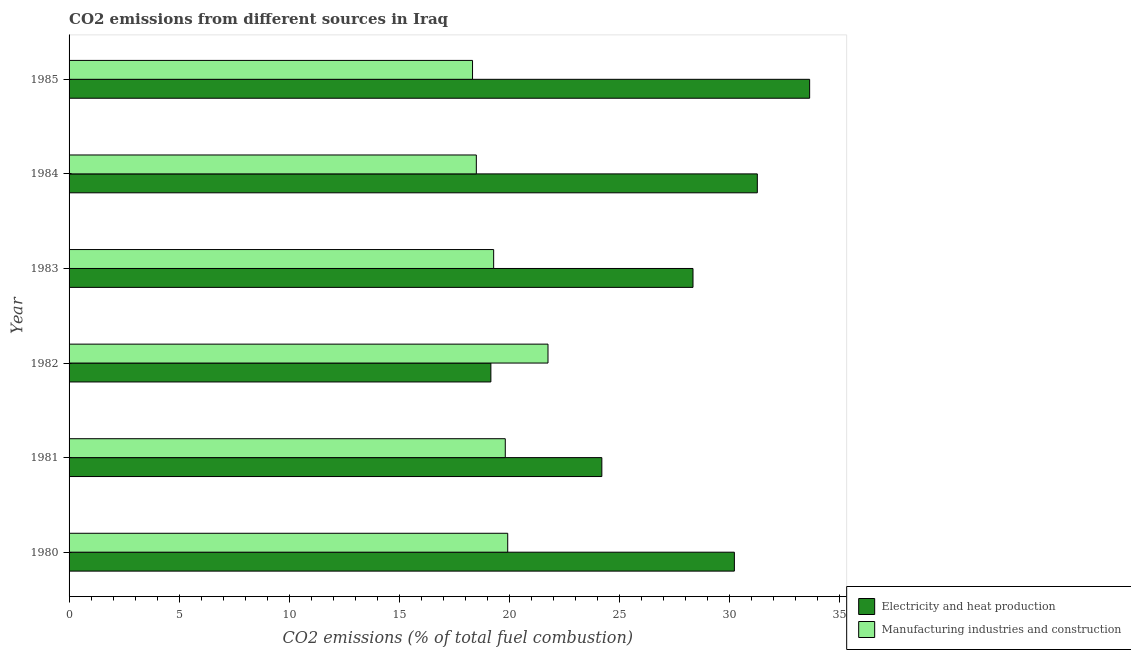How many different coloured bars are there?
Your response must be concise. 2. How many groups of bars are there?
Offer a terse response. 6. Are the number of bars per tick equal to the number of legend labels?
Offer a terse response. Yes. Are the number of bars on each tick of the Y-axis equal?
Provide a succinct answer. Yes. How many bars are there on the 3rd tick from the bottom?
Give a very brief answer. 2. What is the label of the 4th group of bars from the top?
Give a very brief answer. 1982. In how many cases, is the number of bars for a given year not equal to the number of legend labels?
Your answer should be very brief. 0. What is the co2 emissions due to electricity and heat production in 1980?
Provide a succinct answer. 30.22. Across all years, what is the maximum co2 emissions due to electricity and heat production?
Your answer should be compact. 33.64. Across all years, what is the minimum co2 emissions due to manufacturing industries?
Your answer should be very brief. 18.33. In which year was the co2 emissions due to electricity and heat production minimum?
Offer a terse response. 1982. What is the total co2 emissions due to manufacturing industries in the graph?
Offer a terse response. 117.61. What is the difference between the co2 emissions due to manufacturing industries in 1981 and that in 1985?
Provide a succinct answer. 1.49. What is the difference between the co2 emissions due to electricity and heat production in 1985 and the co2 emissions due to manufacturing industries in 1980?
Give a very brief answer. 13.72. What is the average co2 emissions due to manufacturing industries per year?
Ensure brevity in your answer.  19.6. In the year 1981, what is the difference between the co2 emissions due to electricity and heat production and co2 emissions due to manufacturing industries?
Provide a short and direct response. 4.39. What is the ratio of the co2 emissions due to manufacturing industries in 1984 to that in 1985?
Your response must be concise. 1.01. Is the co2 emissions due to manufacturing industries in 1981 less than that in 1983?
Make the answer very short. No. What is the difference between the highest and the second highest co2 emissions due to manufacturing industries?
Your answer should be very brief. 1.83. What is the difference between the highest and the lowest co2 emissions due to manufacturing industries?
Provide a succinct answer. 3.43. In how many years, is the co2 emissions due to electricity and heat production greater than the average co2 emissions due to electricity and heat production taken over all years?
Offer a very short reply. 4. Is the sum of the co2 emissions due to electricity and heat production in 1980 and 1983 greater than the maximum co2 emissions due to manufacturing industries across all years?
Provide a succinct answer. Yes. What does the 1st bar from the top in 1983 represents?
Give a very brief answer. Manufacturing industries and construction. What does the 1st bar from the bottom in 1983 represents?
Keep it short and to the point. Electricity and heat production. How many bars are there?
Keep it short and to the point. 12. Are all the bars in the graph horizontal?
Your answer should be compact. Yes. What is the difference between two consecutive major ticks on the X-axis?
Offer a terse response. 5. Does the graph contain any zero values?
Offer a very short reply. No. Where does the legend appear in the graph?
Ensure brevity in your answer.  Bottom right. What is the title of the graph?
Give a very brief answer. CO2 emissions from different sources in Iraq. What is the label or title of the X-axis?
Your answer should be very brief. CO2 emissions (% of total fuel combustion). What is the label or title of the Y-axis?
Offer a very short reply. Year. What is the CO2 emissions (% of total fuel combustion) in Electricity and heat production in 1980?
Keep it short and to the point. 30.22. What is the CO2 emissions (% of total fuel combustion) of Manufacturing industries and construction in 1980?
Your answer should be compact. 19.93. What is the CO2 emissions (% of total fuel combustion) in Electricity and heat production in 1981?
Your answer should be compact. 24.2. What is the CO2 emissions (% of total fuel combustion) of Manufacturing industries and construction in 1981?
Provide a succinct answer. 19.82. What is the CO2 emissions (% of total fuel combustion) of Electricity and heat production in 1982?
Keep it short and to the point. 19.16. What is the CO2 emissions (% of total fuel combustion) in Manufacturing industries and construction in 1982?
Your answer should be very brief. 21.76. What is the CO2 emissions (% of total fuel combustion) of Electricity and heat production in 1983?
Provide a short and direct response. 28.34. What is the CO2 emissions (% of total fuel combustion) in Manufacturing industries and construction in 1983?
Make the answer very short. 19.29. What is the CO2 emissions (% of total fuel combustion) of Electricity and heat production in 1984?
Offer a very short reply. 31.26. What is the CO2 emissions (% of total fuel combustion) of Manufacturing industries and construction in 1984?
Your response must be concise. 18.5. What is the CO2 emissions (% of total fuel combustion) in Electricity and heat production in 1985?
Your answer should be very brief. 33.64. What is the CO2 emissions (% of total fuel combustion) in Manufacturing industries and construction in 1985?
Give a very brief answer. 18.33. Across all years, what is the maximum CO2 emissions (% of total fuel combustion) in Electricity and heat production?
Provide a succinct answer. 33.64. Across all years, what is the maximum CO2 emissions (% of total fuel combustion) in Manufacturing industries and construction?
Offer a terse response. 21.76. Across all years, what is the minimum CO2 emissions (% of total fuel combustion) in Electricity and heat production?
Make the answer very short. 19.16. Across all years, what is the minimum CO2 emissions (% of total fuel combustion) of Manufacturing industries and construction?
Your response must be concise. 18.33. What is the total CO2 emissions (% of total fuel combustion) in Electricity and heat production in the graph?
Your answer should be compact. 166.83. What is the total CO2 emissions (% of total fuel combustion) in Manufacturing industries and construction in the graph?
Give a very brief answer. 117.61. What is the difference between the CO2 emissions (% of total fuel combustion) of Electricity and heat production in 1980 and that in 1981?
Your response must be concise. 6.02. What is the difference between the CO2 emissions (% of total fuel combustion) in Manufacturing industries and construction in 1980 and that in 1981?
Provide a succinct answer. 0.11. What is the difference between the CO2 emissions (% of total fuel combustion) of Electricity and heat production in 1980 and that in 1982?
Make the answer very short. 11.06. What is the difference between the CO2 emissions (% of total fuel combustion) of Manufacturing industries and construction in 1980 and that in 1982?
Make the answer very short. -1.83. What is the difference between the CO2 emissions (% of total fuel combustion) in Electricity and heat production in 1980 and that in 1983?
Provide a short and direct response. 1.88. What is the difference between the CO2 emissions (% of total fuel combustion) of Manufacturing industries and construction in 1980 and that in 1983?
Make the answer very short. 0.64. What is the difference between the CO2 emissions (% of total fuel combustion) in Electricity and heat production in 1980 and that in 1984?
Your answer should be very brief. -1.04. What is the difference between the CO2 emissions (% of total fuel combustion) of Manufacturing industries and construction in 1980 and that in 1984?
Give a very brief answer. 1.43. What is the difference between the CO2 emissions (% of total fuel combustion) in Electricity and heat production in 1980 and that in 1985?
Keep it short and to the point. -3.42. What is the difference between the CO2 emissions (% of total fuel combustion) in Manufacturing industries and construction in 1980 and that in 1985?
Offer a very short reply. 1.6. What is the difference between the CO2 emissions (% of total fuel combustion) in Electricity and heat production in 1981 and that in 1982?
Make the answer very short. 5.04. What is the difference between the CO2 emissions (% of total fuel combustion) in Manufacturing industries and construction in 1981 and that in 1982?
Your answer should be very brief. -1.94. What is the difference between the CO2 emissions (% of total fuel combustion) of Electricity and heat production in 1981 and that in 1983?
Your answer should be compact. -4.14. What is the difference between the CO2 emissions (% of total fuel combustion) of Manufacturing industries and construction in 1981 and that in 1983?
Your response must be concise. 0.53. What is the difference between the CO2 emissions (% of total fuel combustion) of Electricity and heat production in 1981 and that in 1984?
Keep it short and to the point. -7.06. What is the difference between the CO2 emissions (% of total fuel combustion) of Manufacturing industries and construction in 1981 and that in 1984?
Provide a short and direct response. 1.32. What is the difference between the CO2 emissions (% of total fuel combustion) in Electricity and heat production in 1981 and that in 1985?
Offer a terse response. -9.44. What is the difference between the CO2 emissions (% of total fuel combustion) in Manufacturing industries and construction in 1981 and that in 1985?
Give a very brief answer. 1.49. What is the difference between the CO2 emissions (% of total fuel combustion) of Electricity and heat production in 1982 and that in 1983?
Provide a succinct answer. -9.18. What is the difference between the CO2 emissions (% of total fuel combustion) of Manufacturing industries and construction in 1982 and that in 1983?
Give a very brief answer. 2.47. What is the difference between the CO2 emissions (% of total fuel combustion) in Electricity and heat production in 1982 and that in 1984?
Provide a short and direct response. -12.1. What is the difference between the CO2 emissions (% of total fuel combustion) of Manufacturing industries and construction in 1982 and that in 1984?
Keep it short and to the point. 3.26. What is the difference between the CO2 emissions (% of total fuel combustion) in Electricity and heat production in 1982 and that in 1985?
Provide a short and direct response. -14.48. What is the difference between the CO2 emissions (% of total fuel combustion) of Manufacturing industries and construction in 1982 and that in 1985?
Your response must be concise. 3.43. What is the difference between the CO2 emissions (% of total fuel combustion) in Electricity and heat production in 1983 and that in 1984?
Your answer should be very brief. -2.92. What is the difference between the CO2 emissions (% of total fuel combustion) of Manufacturing industries and construction in 1983 and that in 1984?
Your answer should be compact. 0.79. What is the difference between the CO2 emissions (% of total fuel combustion) in Electricity and heat production in 1983 and that in 1985?
Your answer should be very brief. -5.3. What is the difference between the CO2 emissions (% of total fuel combustion) of Manufacturing industries and construction in 1983 and that in 1985?
Provide a succinct answer. 0.96. What is the difference between the CO2 emissions (% of total fuel combustion) of Electricity and heat production in 1984 and that in 1985?
Provide a succinct answer. -2.38. What is the difference between the CO2 emissions (% of total fuel combustion) in Manufacturing industries and construction in 1984 and that in 1985?
Keep it short and to the point. 0.17. What is the difference between the CO2 emissions (% of total fuel combustion) of Electricity and heat production in 1980 and the CO2 emissions (% of total fuel combustion) of Manufacturing industries and construction in 1981?
Ensure brevity in your answer.  10.41. What is the difference between the CO2 emissions (% of total fuel combustion) in Electricity and heat production in 1980 and the CO2 emissions (% of total fuel combustion) in Manufacturing industries and construction in 1982?
Your response must be concise. 8.47. What is the difference between the CO2 emissions (% of total fuel combustion) of Electricity and heat production in 1980 and the CO2 emissions (% of total fuel combustion) of Manufacturing industries and construction in 1983?
Your response must be concise. 10.93. What is the difference between the CO2 emissions (% of total fuel combustion) in Electricity and heat production in 1980 and the CO2 emissions (% of total fuel combustion) in Manufacturing industries and construction in 1984?
Provide a short and direct response. 11.72. What is the difference between the CO2 emissions (% of total fuel combustion) of Electricity and heat production in 1980 and the CO2 emissions (% of total fuel combustion) of Manufacturing industries and construction in 1985?
Your response must be concise. 11.89. What is the difference between the CO2 emissions (% of total fuel combustion) in Electricity and heat production in 1981 and the CO2 emissions (% of total fuel combustion) in Manufacturing industries and construction in 1982?
Offer a terse response. 2.45. What is the difference between the CO2 emissions (% of total fuel combustion) of Electricity and heat production in 1981 and the CO2 emissions (% of total fuel combustion) of Manufacturing industries and construction in 1983?
Give a very brief answer. 4.91. What is the difference between the CO2 emissions (% of total fuel combustion) in Electricity and heat production in 1981 and the CO2 emissions (% of total fuel combustion) in Manufacturing industries and construction in 1984?
Ensure brevity in your answer.  5.7. What is the difference between the CO2 emissions (% of total fuel combustion) in Electricity and heat production in 1981 and the CO2 emissions (% of total fuel combustion) in Manufacturing industries and construction in 1985?
Offer a terse response. 5.87. What is the difference between the CO2 emissions (% of total fuel combustion) in Electricity and heat production in 1982 and the CO2 emissions (% of total fuel combustion) in Manufacturing industries and construction in 1983?
Make the answer very short. -0.13. What is the difference between the CO2 emissions (% of total fuel combustion) of Electricity and heat production in 1982 and the CO2 emissions (% of total fuel combustion) of Manufacturing industries and construction in 1984?
Give a very brief answer. 0.66. What is the difference between the CO2 emissions (% of total fuel combustion) of Electricity and heat production in 1982 and the CO2 emissions (% of total fuel combustion) of Manufacturing industries and construction in 1985?
Offer a very short reply. 0.83. What is the difference between the CO2 emissions (% of total fuel combustion) in Electricity and heat production in 1983 and the CO2 emissions (% of total fuel combustion) in Manufacturing industries and construction in 1984?
Your answer should be very brief. 9.84. What is the difference between the CO2 emissions (% of total fuel combustion) of Electricity and heat production in 1983 and the CO2 emissions (% of total fuel combustion) of Manufacturing industries and construction in 1985?
Give a very brief answer. 10.02. What is the difference between the CO2 emissions (% of total fuel combustion) of Electricity and heat production in 1984 and the CO2 emissions (% of total fuel combustion) of Manufacturing industries and construction in 1985?
Offer a terse response. 12.94. What is the average CO2 emissions (% of total fuel combustion) in Electricity and heat production per year?
Make the answer very short. 27.81. What is the average CO2 emissions (% of total fuel combustion) of Manufacturing industries and construction per year?
Provide a short and direct response. 19.6. In the year 1980, what is the difference between the CO2 emissions (% of total fuel combustion) in Electricity and heat production and CO2 emissions (% of total fuel combustion) in Manufacturing industries and construction?
Your response must be concise. 10.3. In the year 1981, what is the difference between the CO2 emissions (% of total fuel combustion) in Electricity and heat production and CO2 emissions (% of total fuel combustion) in Manufacturing industries and construction?
Give a very brief answer. 4.39. In the year 1982, what is the difference between the CO2 emissions (% of total fuel combustion) of Electricity and heat production and CO2 emissions (% of total fuel combustion) of Manufacturing industries and construction?
Offer a very short reply. -2.6. In the year 1983, what is the difference between the CO2 emissions (% of total fuel combustion) in Electricity and heat production and CO2 emissions (% of total fuel combustion) in Manufacturing industries and construction?
Keep it short and to the point. 9.06. In the year 1984, what is the difference between the CO2 emissions (% of total fuel combustion) in Electricity and heat production and CO2 emissions (% of total fuel combustion) in Manufacturing industries and construction?
Your response must be concise. 12.76. In the year 1985, what is the difference between the CO2 emissions (% of total fuel combustion) in Electricity and heat production and CO2 emissions (% of total fuel combustion) in Manufacturing industries and construction?
Provide a succinct answer. 15.31. What is the ratio of the CO2 emissions (% of total fuel combustion) in Electricity and heat production in 1980 to that in 1981?
Provide a succinct answer. 1.25. What is the ratio of the CO2 emissions (% of total fuel combustion) of Manufacturing industries and construction in 1980 to that in 1981?
Provide a succinct answer. 1.01. What is the ratio of the CO2 emissions (% of total fuel combustion) in Electricity and heat production in 1980 to that in 1982?
Keep it short and to the point. 1.58. What is the ratio of the CO2 emissions (% of total fuel combustion) of Manufacturing industries and construction in 1980 to that in 1982?
Make the answer very short. 0.92. What is the ratio of the CO2 emissions (% of total fuel combustion) in Electricity and heat production in 1980 to that in 1983?
Provide a succinct answer. 1.07. What is the ratio of the CO2 emissions (% of total fuel combustion) of Manufacturing industries and construction in 1980 to that in 1983?
Your response must be concise. 1.03. What is the ratio of the CO2 emissions (% of total fuel combustion) in Electricity and heat production in 1980 to that in 1984?
Give a very brief answer. 0.97. What is the ratio of the CO2 emissions (% of total fuel combustion) of Manufacturing industries and construction in 1980 to that in 1984?
Provide a succinct answer. 1.08. What is the ratio of the CO2 emissions (% of total fuel combustion) of Electricity and heat production in 1980 to that in 1985?
Make the answer very short. 0.9. What is the ratio of the CO2 emissions (% of total fuel combustion) in Manufacturing industries and construction in 1980 to that in 1985?
Give a very brief answer. 1.09. What is the ratio of the CO2 emissions (% of total fuel combustion) of Electricity and heat production in 1981 to that in 1982?
Your answer should be compact. 1.26. What is the ratio of the CO2 emissions (% of total fuel combustion) in Manufacturing industries and construction in 1981 to that in 1982?
Your answer should be very brief. 0.91. What is the ratio of the CO2 emissions (% of total fuel combustion) of Electricity and heat production in 1981 to that in 1983?
Your answer should be very brief. 0.85. What is the ratio of the CO2 emissions (% of total fuel combustion) in Manufacturing industries and construction in 1981 to that in 1983?
Your response must be concise. 1.03. What is the ratio of the CO2 emissions (% of total fuel combustion) of Electricity and heat production in 1981 to that in 1984?
Provide a short and direct response. 0.77. What is the ratio of the CO2 emissions (% of total fuel combustion) in Manufacturing industries and construction in 1981 to that in 1984?
Ensure brevity in your answer.  1.07. What is the ratio of the CO2 emissions (% of total fuel combustion) of Electricity and heat production in 1981 to that in 1985?
Keep it short and to the point. 0.72. What is the ratio of the CO2 emissions (% of total fuel combustion) in Manufacturing industries and construction in 1981 to that in 1985?
Ensure brevity in your answer.  1.08. What is the ratio of the CO2 emissions (% of total fuel combustion) in Electricity and heat production in 1982 to that in 1983?
Give a very brief answer. 0.68. What is the ratio of the CO2 emissions (% of total fuel combustion) of Manufacturing industries and construction in 1982 to that in 1983?
Ensure brevity in your answer.  1.13. What is the ratio of the CO2 emissions (% of total fuel combustion) of Electricity and heat production in 1982 to that in 1984?
Keep it short and to the point. 0.61. What is the ratio of the CO2 emissions (% of total fuel combustion) of Manufacturing industries and construction in 1982 to that in 1984?
Make the answer very short. 1.18. What is the ratio of the CO2 emissions (% of total fuel combustion) of Electricity and heat production in 1982 to that in 1985?
Offer a very short reply. 0.57. What is the ratio of the CO2 emissions (% of total fuel combustion) in Manufacturing industries and construction in 1982 to that in 1985?
Provide a succinct answer. 1.19. What is the ratio of the CO2 emissions (% of total fuel combustion) in Electricity and heat production in 1983 to that in 1984?
Your answer should be very brief. 0.91. What is the ratio of the CO2 emissions (% of total fuel combustion) of Manufacturing industries and construction in 1983 to that in 1984?
Your response must be concise. 1.04. What is the ratio of the CO2 emissions (% of total fuel combustion) in Electricity and heat production in 1983 to that in 1985?
Offer a terse response. 0.84. What is the ratio of the CO2 emissions (% of total fuel combustion) in Manufacturing industries and construction in 1983 to that in 1985?
Offer a very short reply. 1.05. What is the ratio of the CO2 emissions (% of total fuel combustion) of Electricity and heat production in 1984 to that in 1985?
Ensure brevity in your answer.  0.93. What is the ratio of the CO2 emissions (% of total fuel combustion) in Manufacturing industries and construction in 1984 to that in 1985?
Offer a very short reply. 1.01. What is the difference between the highest and the second highest CO2 emissions (% of total fuel combustion) in Electricity and heat production?
Give a very brief answer. 2.38. What is the difference between the highest and the second highest CO2 emissions (% of total fuel combustion) of Manufacturing industries and construction?
Your answer should be compact. 1.83. What is the difference between the highest and the lowest CO2 emissions (% of total fuel combustion) of Electricity and heat production?
Keep it short and to the point. 14.48. What is the difference between the highest and the lowest CO2 emissions (% of total fuel combustion) in Manufacturing industries and construction?
Provide a short and direct response. 3.43. 